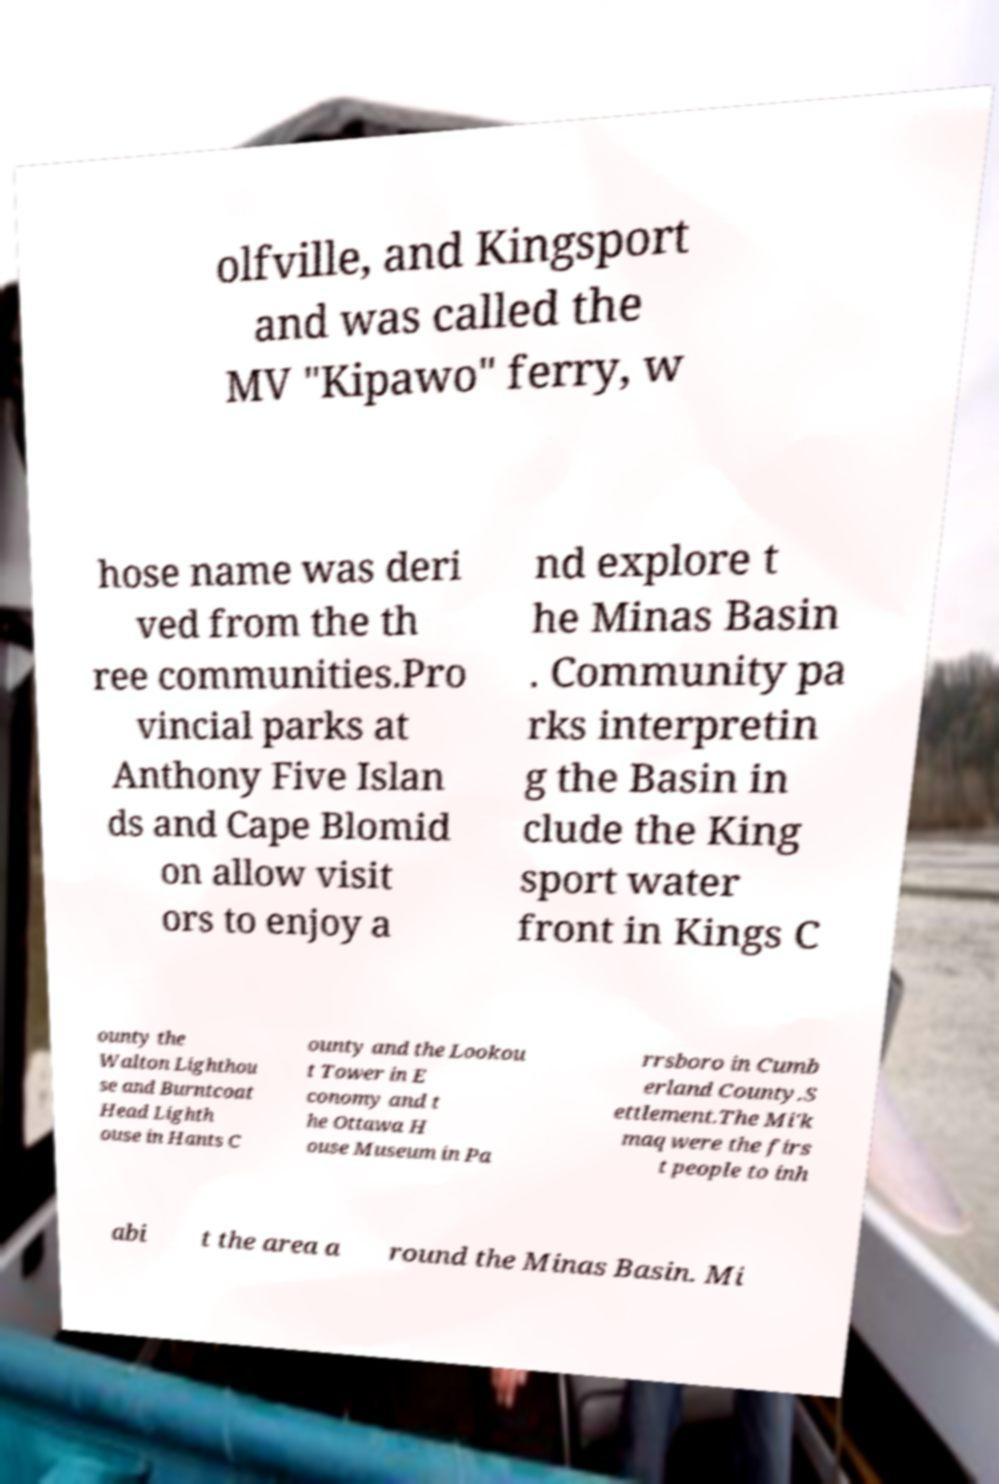There's text embedded in this image that I need extracted. Can you transcribe it verbatim? olfville, and Kingsport and was called the MV "Kipawo" ferry, w hose name was deri ved from the th ree communities.Pro vincial parks at Anthony Five Islan ds and Cape Blomid on allow visit ors to enjoy a nd explore t he Minas Basin . Community pa rks interpretin g the Basin in clude the King sport water front in Kings C ounty the Walton Lighthou se and Burntcoat Head Lighth ouse in Hants C ounty and the Lookou t Tower in E conomy and t he Ottawa H ouse Museum in Pa rrsboro in Cumb erland County.S ettlement.The Mi'k maq were the firs t people to inh abi t the area a round the Minas Basin. Mi 